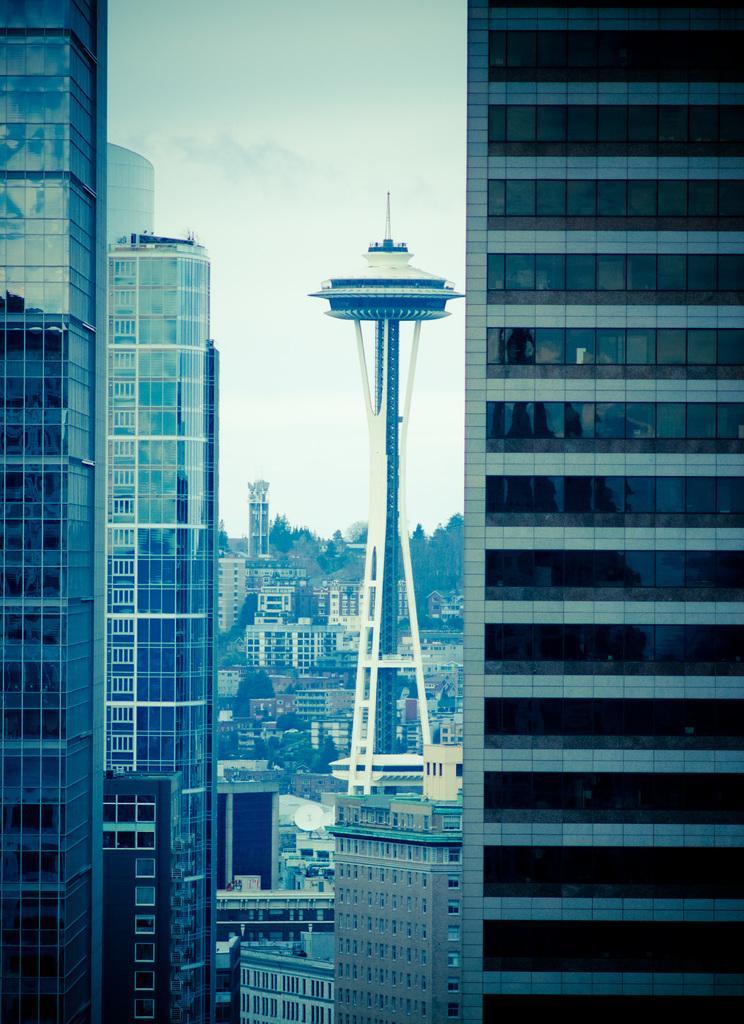Please provide a concise description of this image. In this image there are buildings. In the center there is a tower. In the background there are trees and sky. 